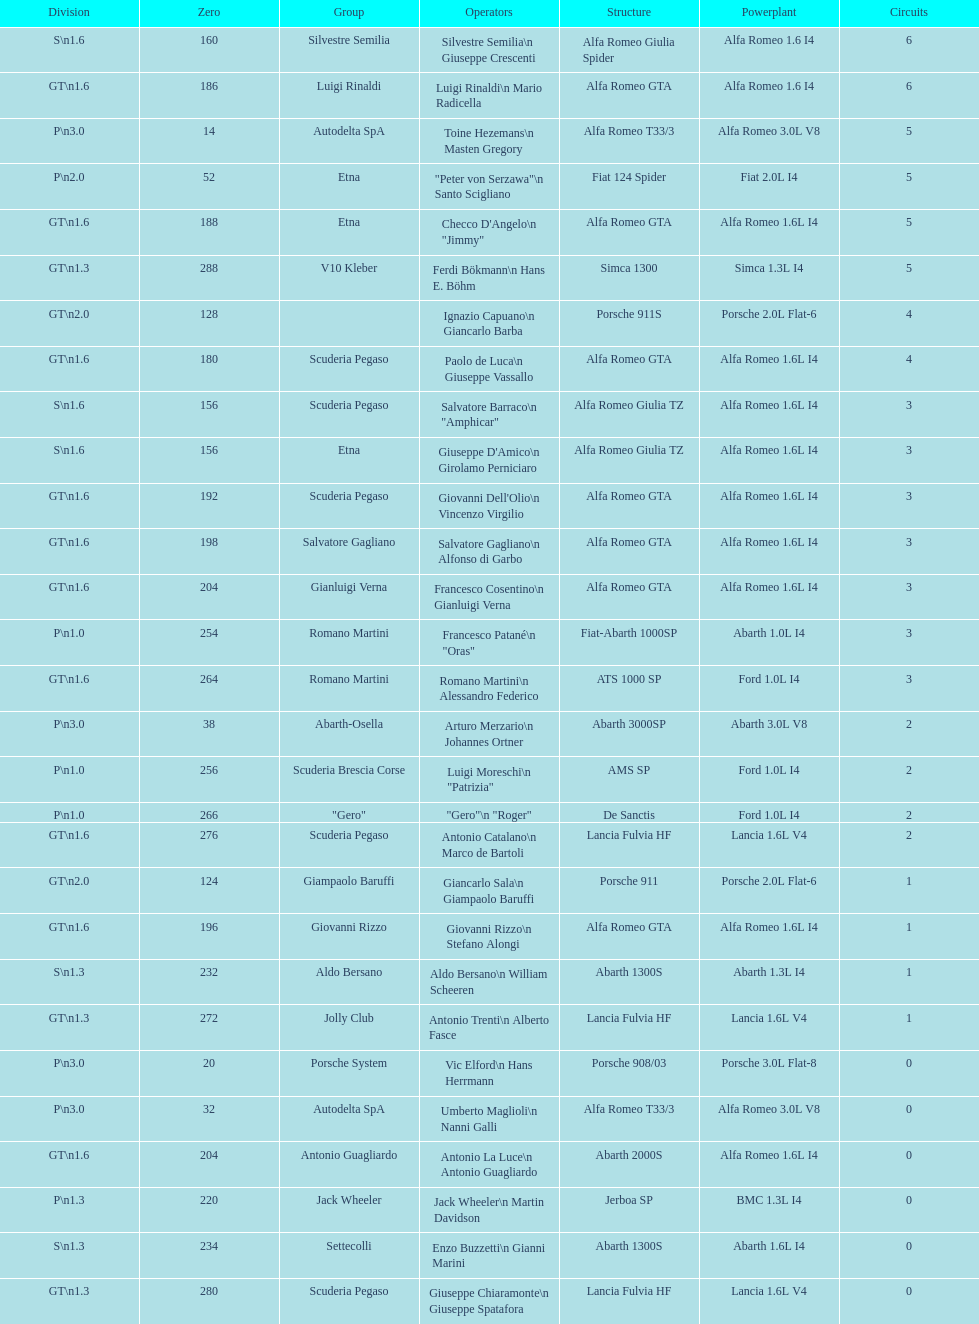How many laps does v10 kleber have? 5. 